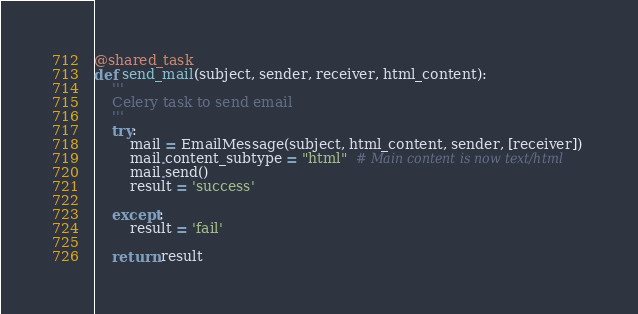<code> <loc_0><loc_0><loc_500><loc_500><_Python_>@shared_task
def send_mail(subject, sender, receiver, html_content):
    '''
    Celery task to send email
    '''
    try:
        mail = EmailMessage(subject, html_content, sender, [receiver])
        mail.content_subtype = "html"  # Main content is now text/html
        mail.send()
        result = 'success'

    except:
        result = 'fail'

    return result
</code> 